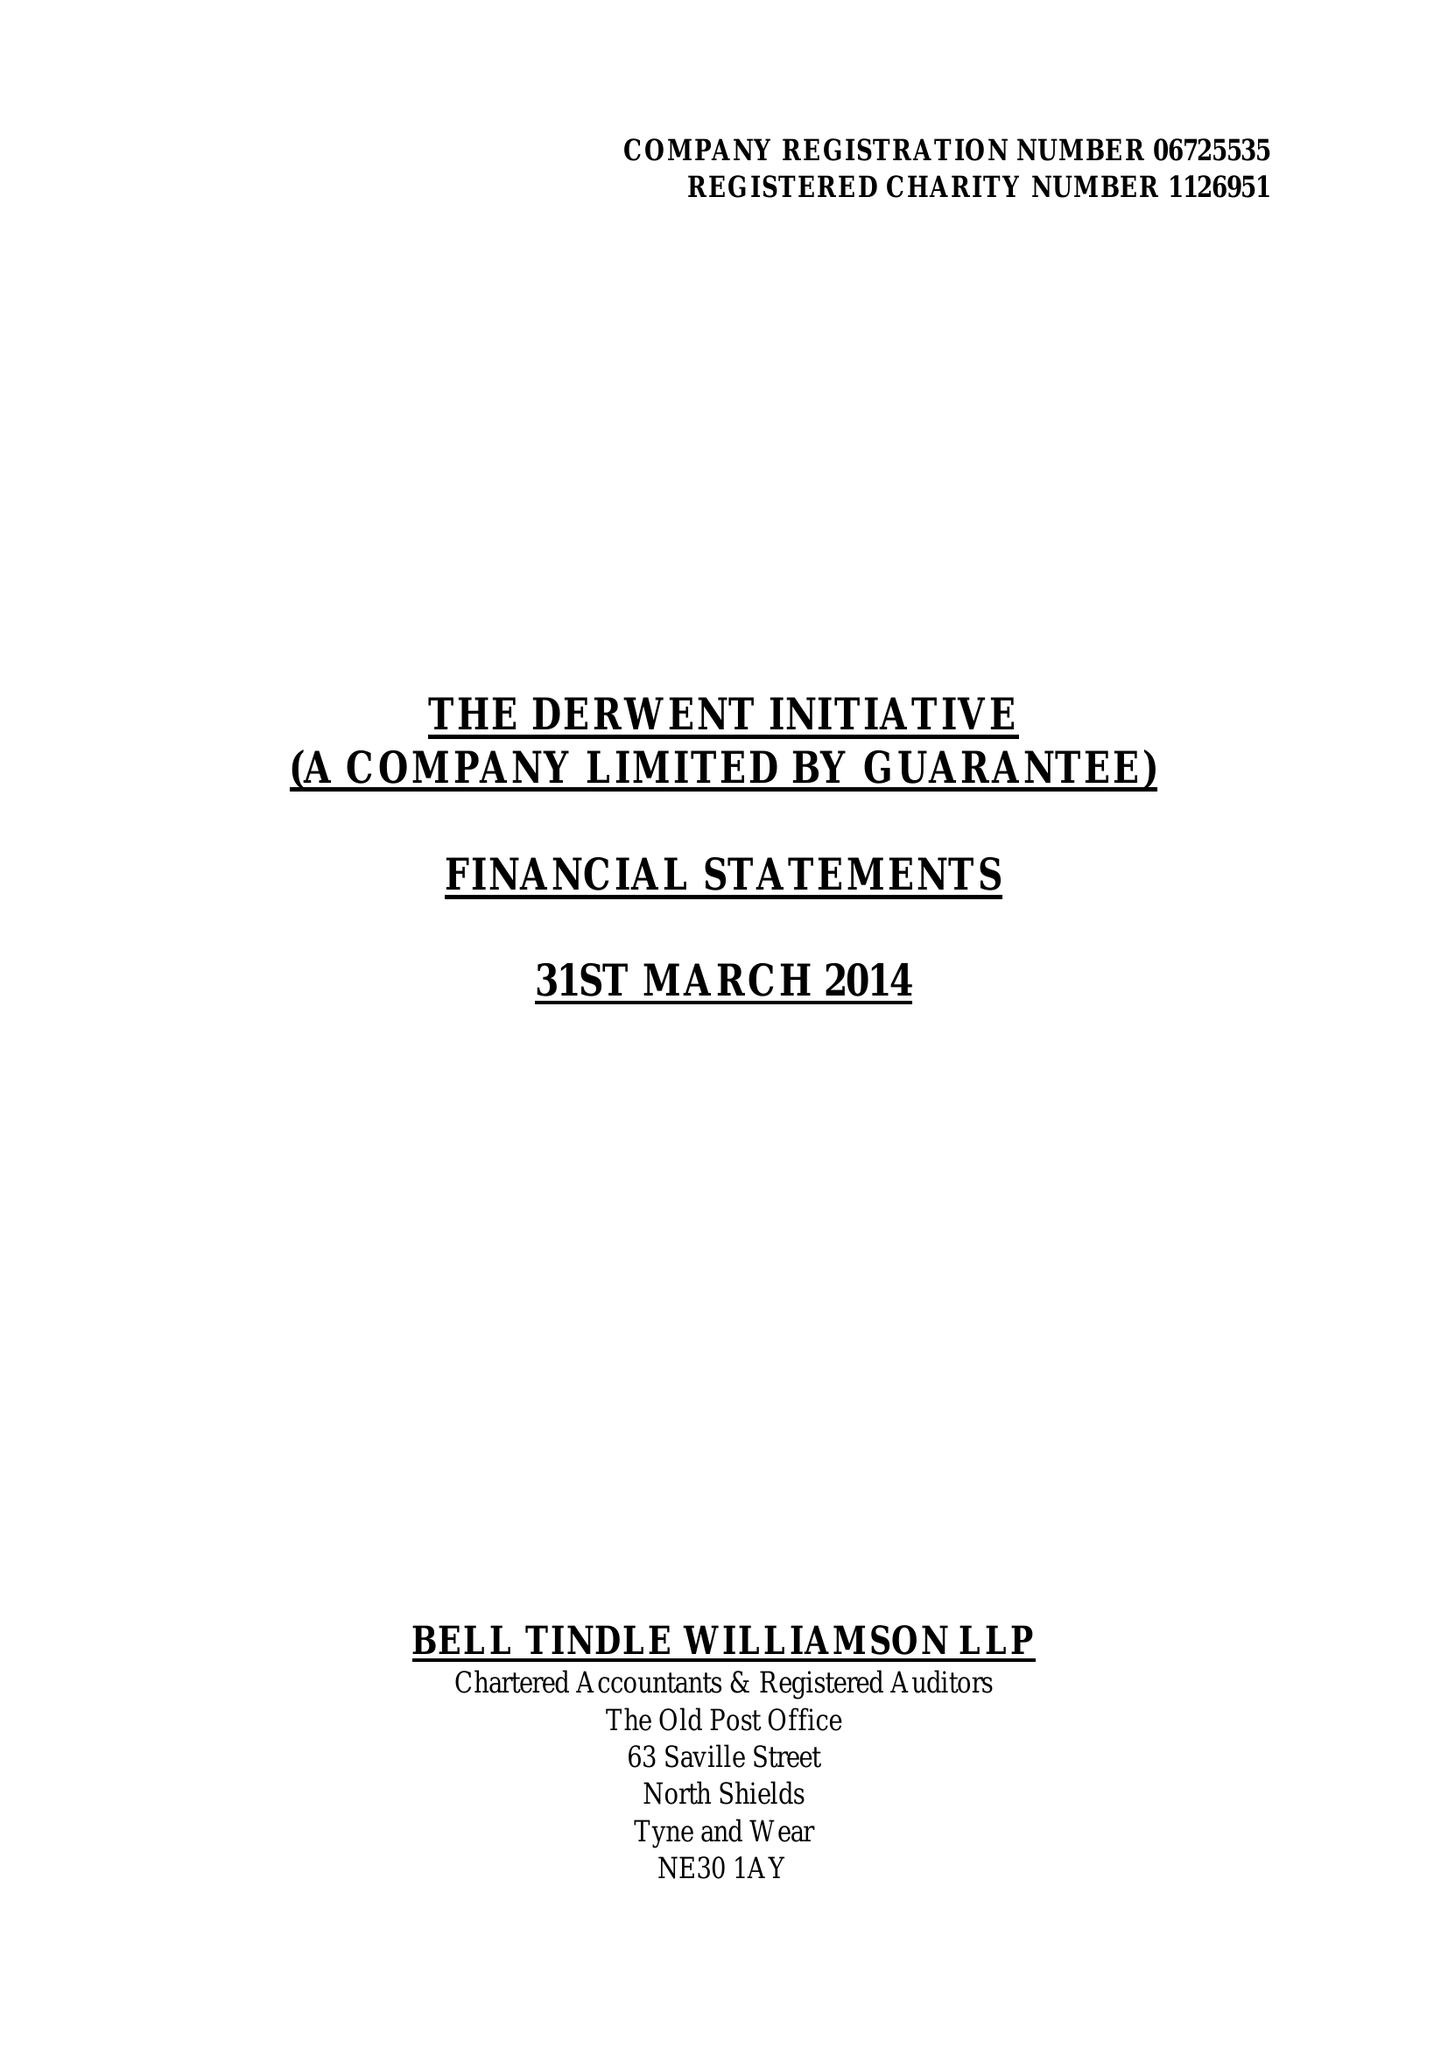What is the value for the report_date?
Answer the question using a single word or phrase. 2014-03-31 